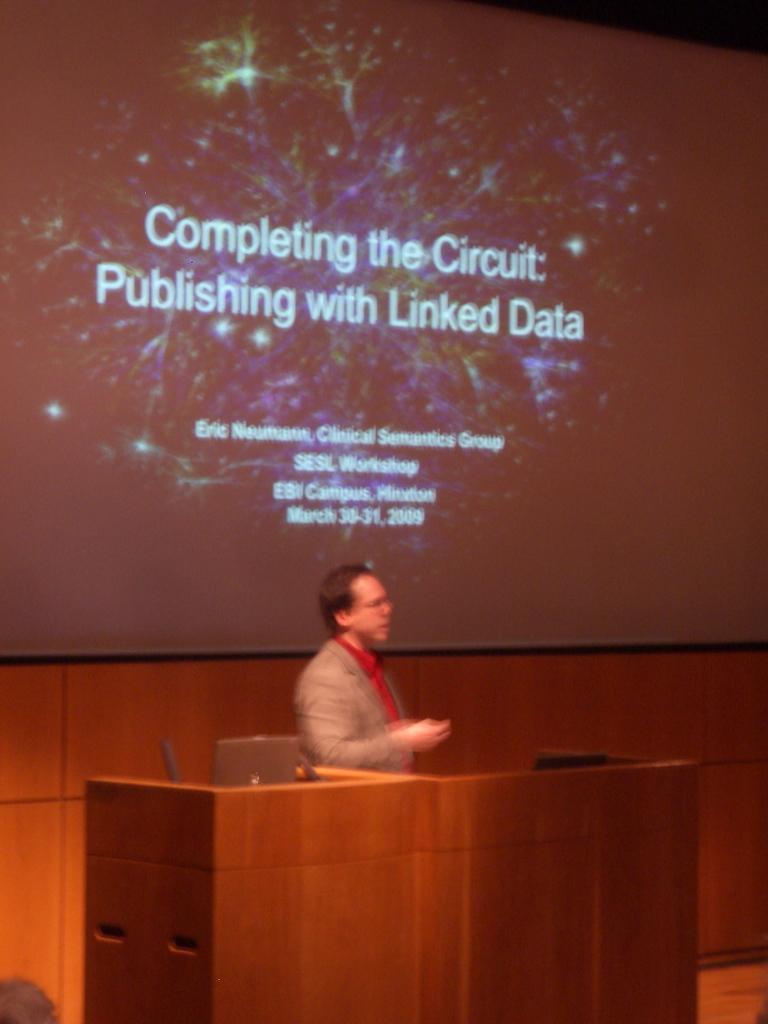Please provide a concise description of this image. In this image we can see a person standing on the stage, in front of the person there is a table. On the table there is a laptop and other objects. In the background there is a screen. 